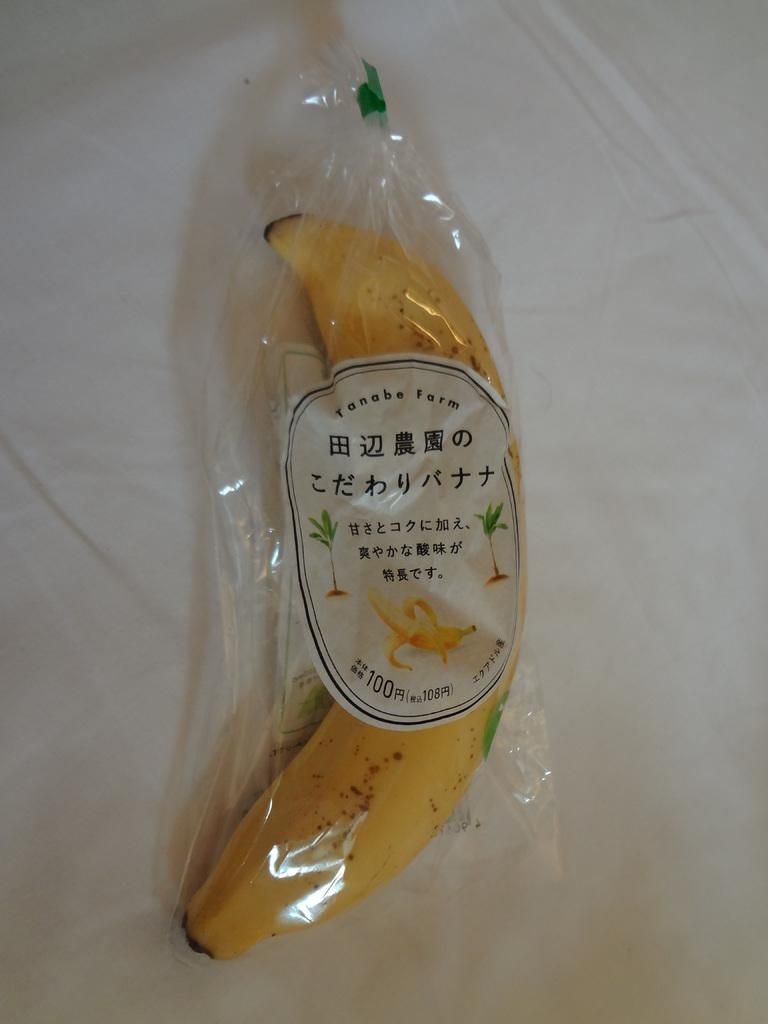<image>
Describe the image concisely. The banana from Tanabe Farm is wrapped in plastic. 